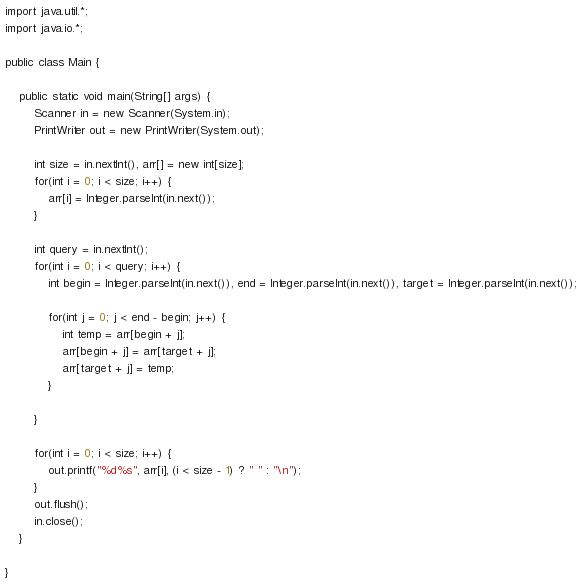Convert code to text. <code><loc_0><loc_0><loc_500><loc_500><_Java_>import java.util.*;
import java.io.*;

public class Main {

	public static void main(String[] args) {
		Scanner in = new Scanner(System.in);
		PrintWriter out = new PrintWriter(System.out);

		int size = in.nextInt(), arr[] = new int[size];
		for(int i = 0; i < size; i++) {
			arr[i] = Integer.parseInt(in.next());
		}

		int query = in.nextInt();
		for(int i = 0; i < query; i++) {
			int begin = Integer.parseInt(in.next()), end = Integer.parseInt(in.next()), target = Integer.parseInt(in.next());

			for(int j = 0; j < end - begin; j++) {
				int temp = arr[begin + j];
				arr[begin + j] = arr[target + j];
				arr[target + j] = temp;
			}

		}

		for(int i = 0; i < size; i++) {
			out.printf("%d%s", arr[i], (i < size - 1) ? " " : "\n");
		}
		out.flush();
		in.close();
	}

}

</code> 